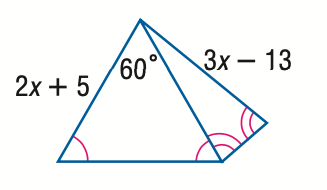Question: Find x.
Choices:
A. 8
B. 13
C. 18
D. 23
Answer with the letter. Answer: C 